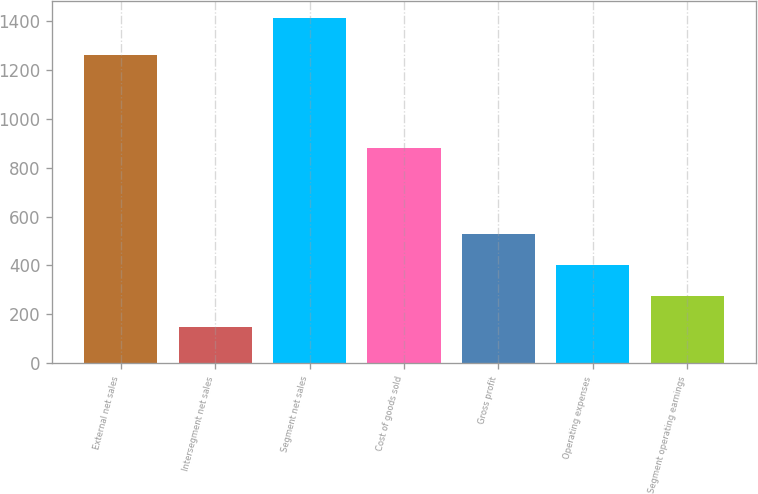<chart> <loc_0><loc_0><loc_500><loc_500><bar_chart><fcel>External net sales<fcel>Intersegment net sales<fcel>Segment net sales<fcel>Cost of goods sold<fcel>Gross profit<fcel>Operating expenses<fcel>Segment operating earnings<nl><fcel>1260.5<fcel>148.8<fcel>1409.3<fcel>878.9<fcel>530.4<fcel>400.9<fcel>274.85<nl></chart> 